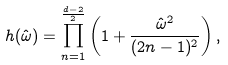<formula> <loc_0><loc_0><loc_500><loc_500>h ( \hat { \omega } ) = \prod _ { n = 1 } ^ { \frac { d - 2 } { 2 } } \left ( 1 + \frac { \hat { \omega } ^ { 2 } } { ( 2 n - 1 ) ^ { 2 } } \right ) ,</formula> 